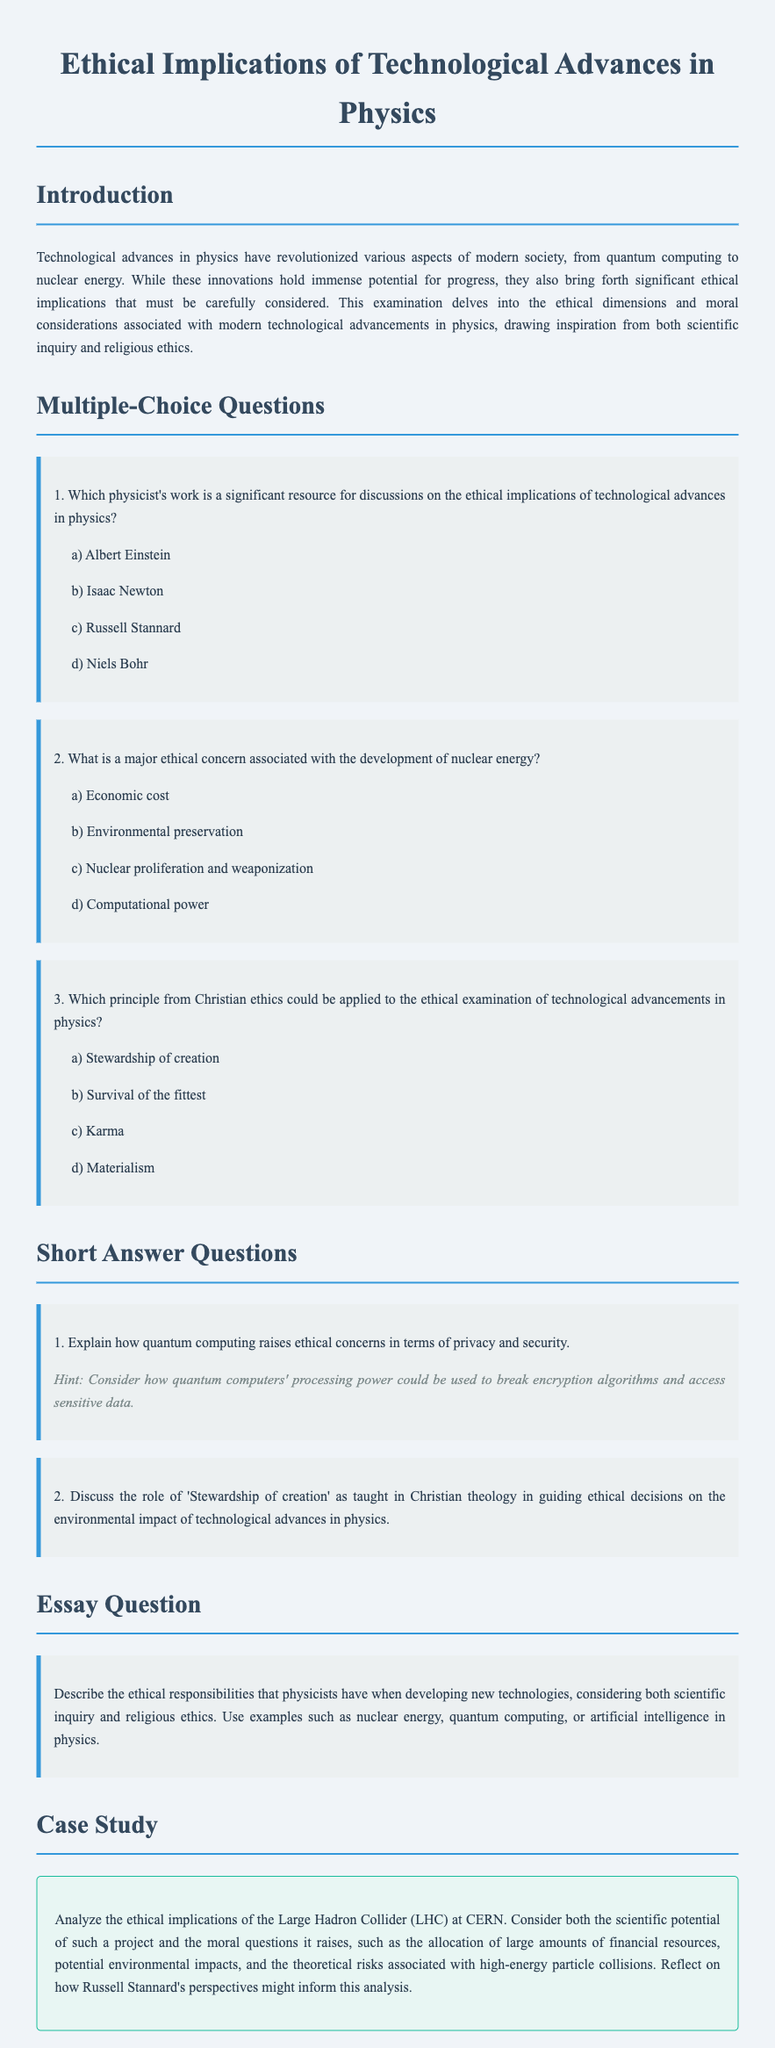Which physicist's work is a significant resource for discussions on the ethical implications of technological advances in physics? The document mentions that Russell Stannard's work is significant for discussions on ethical implications in physics.
Answer: Russell Stannard What is a major ethical concern associated with the development of nuclear energy? The document lists nuclear proliferation and weaponization as a major ethical concern associated with nuclear energy.
Answer: Nuclear proliferation and weaponization Which principle from Christian ethics could be applied to the ethical examination of technological advancements in physics? The principle of stewardship of creation is mentioned as applicable to the ethical examination of technological advancements in physics.
Answer: Stewardship of creation What technological advance raises ethical concerns in terms of privacy and security? The document specifically states that quantum computing raises ethical concerns regarding privacy and security.
Answer: Quantum computing What does the case study analyze regarding the Large Hadron Collider? The case study analyzes the ethical implications including financial resources, environmental impacts, and theoretical risks of the LHC.
Answer: Ethical implications of the LHC How does the document categorize the questions about technological advancements in physics? The questions are categorized into multiple-choice questions, short answer questions, an essay question, and a case study.
Answer: Multiple choice, short answer, essay, case study 